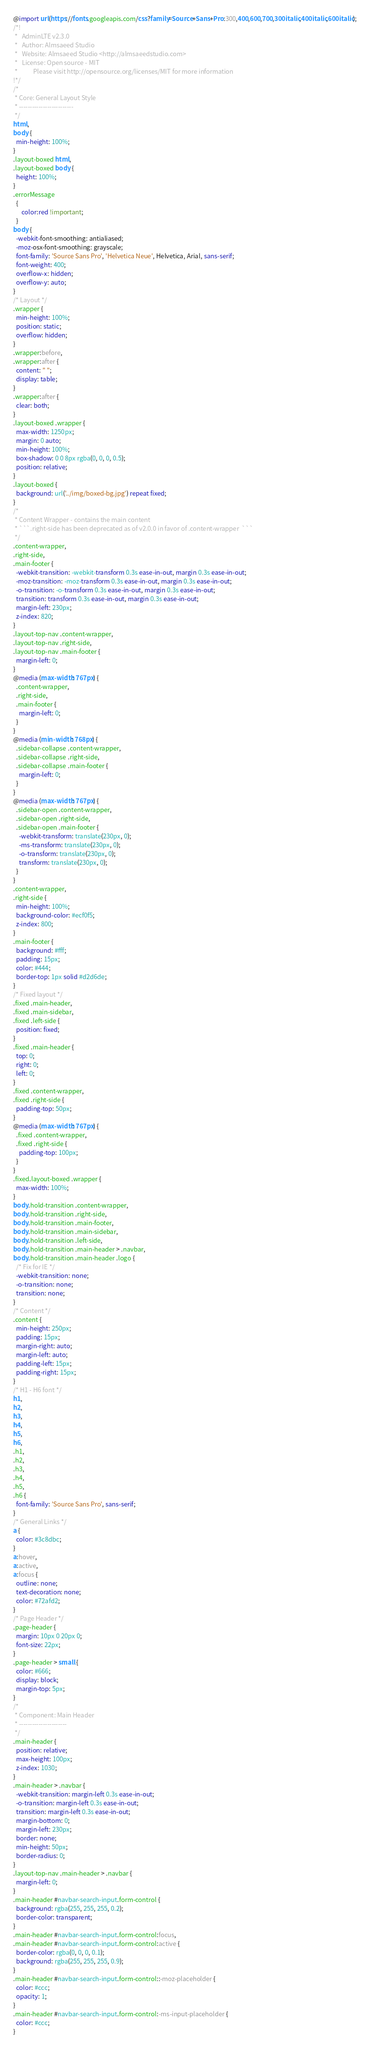<code> <loc_0><loc_0><loc_500><loc_500><_CSS_>@import url(https://fonts.googleapis.com/css?family=Source+Sans+Pro:300,400,600,700,300italic,400italic,600italic);
/*!
 *   AdminLTE v2.3.0
 *   Author: Almsaeed Studio
 *	 Website: Almsaeed Studio <http://almsaeedstudio.com>
 *   License: Open source - MIT
 *           Please visit http://opensource.org/licenses/MIT for more information
!*/
/*
 * Core: General Layout Style
 * -------------------------
 */
html,
body {
  min-height: 100%;
}
.layout-boxed html,
.layout-boxed body {
  height: 100%;
}
.errorMessage
  {
      color:red !important;
  }
body {
  -webkit-font-smoothing: antialiased;
  -moz-osx-font-smoothing: grayscale;
  font-family: 'Source Sans Pro', 'Helvetica Neue', Helvetica, Arial, sans-serif;
  font-weight: 400;
  overflow-x: hidden;
  overflow-y: auto;
}
/* Layout */
.wrapper {
  min-height: 100%;
  position: static;
  overflow: hidden;
}
.wrapper:before,
.wrapper:after {
  content: " ";
  display: table;
}
.wrapper:after {
  clear: both;
}
.layout-boxed .wrapper {
  max-width: 1250px;
  margin: 0 auto;
  min-height: 100%;
  box-shadow: 0 0 8px rgba(0, 0, 0, 0.5);
  position: relative;
}
.layout-boxed {
  background: url('../img/boxed-bg.jpg') repeat fixed;
}
/*
 * Content Wrapper - contains the main content
 * ```.right-side has been deprecated as of v2.0.0 in favor of .content-wrapper  ```
 */
.content-wrapper,
.right-side,
.main-footer {
  -webkit-transition: -webkit-transform 0.3s ease-in-out, margin 0.3s ease-in-out;
  -moz-transition: -moz-transform 0.3s ease-in-out, margin 0.3s ease-in-out;
  -o-transition: -o-transform 0.3s ease-in-out, margin 0.3s ease-in-out;
  transition: transform 0.3s ease-in-out, margin 0.3s ease-in-out;
  margin-left: 230px;
  z-index: 820;
}
.layout-top-nav .content-wrapper,
.layout-top-nav .right-side,
.layout-top-nav .main-footer {
  margin-left: 0;
}
@media (max-width: 767px) {
  .content-wrapper,
  .right-side,
  .main-footer {
    margin-left: 0;
  }
}
@media (min-width: 768px) {
  .sidebar-collapse .content-wrapper,
  .sidebar-collapse .right-side,
  .sidebar-collapse .main-footer {
    margin-left: 0;
  }
}
@media (max-width: 767px) {
  .sidebar-open .content-wrapper,
  .sidebar-open .right-side,
  .sidebar-open .main-footer {
    -webkit-transform: translate(230px, 0);
    -ms-transform: translate(230px, 0);
    -o-transform: translate(230px, 0);
    transform: translate(230px, 0);
  }
}
.content-wrapper,
.right-side {
  min-height: 100%;
  background-color: #ecf0f5;
  z-index: 800;
}
.main-footer {
  background: #fff;
  padding: 15px;
  color: #444;
  border-top: 1px solid #d2d6de;
}
/* Fixed layout */
.fixed .main-header,
.fixed .main-sidebar,
.fixed .left-side {
  position: fixed;
}
.fixed .main-header {
  top: 0;
  right: 0;
  left: 0;
}
.fixed .content-wrapper,
.fixed .right-side {
  padding-top: 50px;
}
@media (max-width: 767px) {
  .fixed .content-wrapper,
  .fixed .right-side {
    padding-top: 100px;
  }
}
.fixed.layout-boxed .wrapper {
  max-width: 100%;
}
body.hold-transition .content-wrapper,
body.hold-transition .right-side,
body.hold-transition .main-footer,
body.hold-transition .main-sidebar,
body.hold-transition .left-side,
body.hold-transition .main-header > .navbar,
body.hold-transition .main-header .logo {
  /* Fix for IE */
  -webkit-transition: none;
  -o-transition: none;
  transition: none;
}
/* Content */
.content {
  min-height: 250px;
  padding: 15px;
  margin-right: auto;
  margin-left: auto;
  padding-left: 15px;
  padding-right: 15px;
}
/* H1 - H6 font */
h1,
h2,
h3,
h4,
h5,
h6,
.h1,
.h2,
.h3,
.h4,
.h5,
.h6 {
  font-family: 'Source Sans Pro', sans-serif;
}
/* General Links */
a {
  color: #3c8dbc;
}
a:hover,
a:active,
a:focus {
  outline: none;
  text-decoration: none;
  color: #72afd2;
}
/* Page Header */
.page-header {
  margin: 10px 0 20px 0;
  font-size: 22px;
}
.page-header > small {
  color: #666;
  display: block;
  margin-top: 5px;
}
/*
 * Component: Main Header
 * ----------------------
 */
.main-header {
  position: relative;
  max-height: 100px;
  z-index: 1030;
}
.main-header > .navbar {
  -webkit-transition: margin-left 0.3s ease-in-out;
  -o-transition: margin-left 0.3s ease-in-out;
  transition: margin-left 0.3s ease-in-out;
  margin-bottom: 0;
  margin-left: 230px;
  border: none;
  min-height: 50px;
  border-radius: 0;
}
.layout-top-nav .main-header > .navbar {
  margin-left: 0;
}
.main-header #navbar-search-input.form-control {
  background: rgba(255, 255, 255, 0.2);
  border-color: transparent;
}
.main-header #navbar-search-input.form-control:focus,
.main-header #navbar-search-input.form-control:active {
  border-color: rgba(0, 0, 0, 0.1);
  background: rgba(255, 255, 255, 0.9);
}
.main-header #navbar-search-input.form-control::-moz-placeholder {
  color: #ccc;
  opacity: 1;
}
.main-header #navbar-search-input.form-control:-ms-input-placeholder {
  color: #ccc;
}</code> 